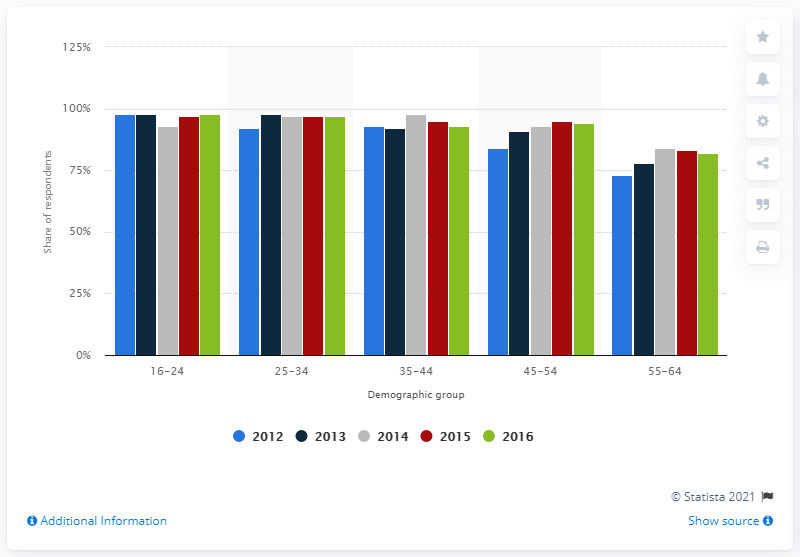How has internet usage changed for the 55-64 age group from 2012 to 2016? According to the chart, in the 55-64 age group, internet usage has shown a general increase from 2012 to 2016. It started at just under 75% in 2012 and saw a gradual growth over the years, reaching just over 75% by 2016. The trend suggests that internet adoption among this demographic has been slowly rising. 